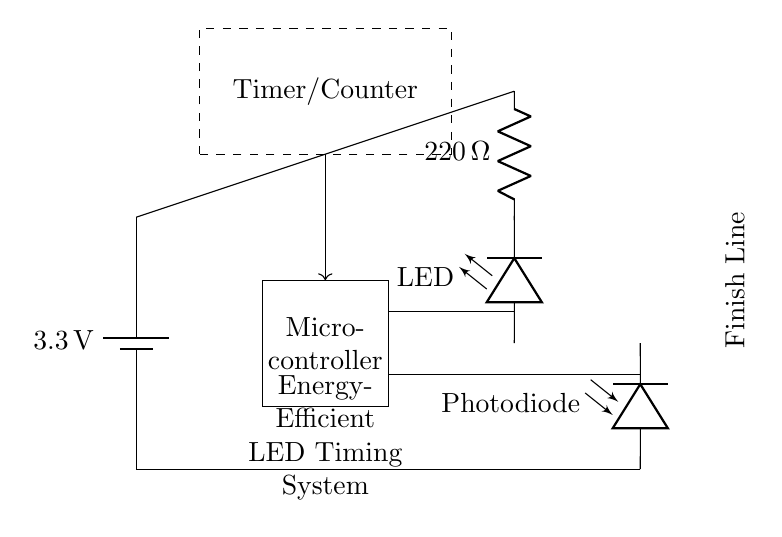What is the voltage of the power supply in the circuit? The circuit uses a battery with a labeled voltage of 3.3 volts. This can be found at the leftmost part of the circuit diagram, where the battery symbol indicates the voltage supplied to the components.
Answer: 3.3 volts What type of LED is used in this circuit? The circuit diagram specifically labels a component as a LED, which indicates that a light-emitting diode is included for visual signaling during the timing mechanism. The designation "LED" confirms its type.
Answer: LED What is the resistance value of the resistor in the circuit? A resistor in the circuit is labeled with a resistance value of 220 ohms. This is indicated in the middle section of the circuit diagram where the resistor symbol is present.
Answer: 220 ohms Which component detects the finish line in the training system? The photodiode in the circuit is responsible for detecting light or changes in light intensity at the finish line, as indicated by the labeled photodiode symbol in the diagram.
Answer: Photodiode How does the microcontroller interact with the timer/counter in the circuit? The microcontroller is connected to the timer/counter via a direct line. The microcontroller processes signals and interacts to start or stop the timing mechanism based on inputs from the photodiode. This connection is shown by the line drawn between the microcontroller and the timer/counter, indicating that they work together in the system's operation.
Answer: Direct connection What is the purpose of the timer/counter in this circuit? The timer/counter is used to measure time intervals for the sprint training accurately. It counts time when triggered by signals from the photodiode when a runner crosses the finish line. This function is represented by the dashed rectangle labeled as Timer/Counter in the circuit.
Answer: Timing intervals 